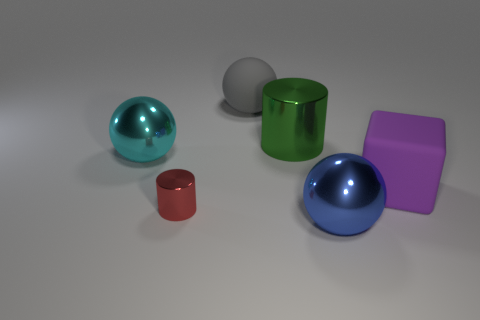There is a big sphere that is the same material as the cyan object; what is its color? blue 